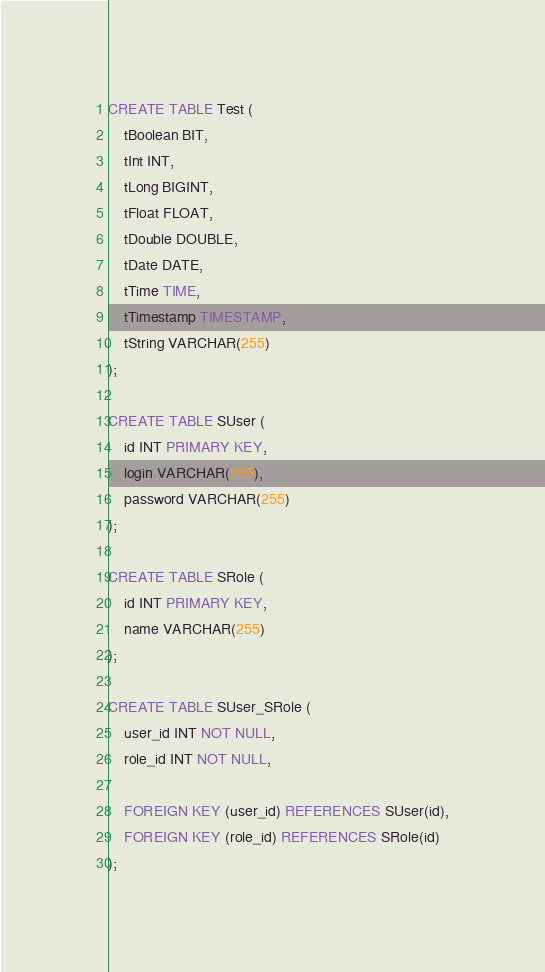Convert code to text. <code><loc_0><loc_0><loc_500><loc_500><_SQL_>CREATE TABLE Test (
    tBoolean BIT,
    tInt INT,
    tLong BIGINT,
    tFloat FLOAT,
    tDouble DOUBLE,
    tDate DATE,
    tTime TIME,
    tTimestamp TIMESTAMP,
    tString VARCHAR(255)
);

CREATE TABLE SUser (
    id INT PRIMARY KEY,
    login VARCHAR(255),
    password VARCHAR(255)
);

CREATE TABLE SRole (
    id INT PRIMARY KEY,
    name VARCHAR(255)
);

CREATE TABLE SUser_SRole (
    user_id INT NOT NULL,
    role_id INT NOT NULL,

    FOREIGN KEY (user_id) REFERENCES SUser(id),
    FOREIGN KEY (role_id) REFERENCES SRole(id)
);
</code> 